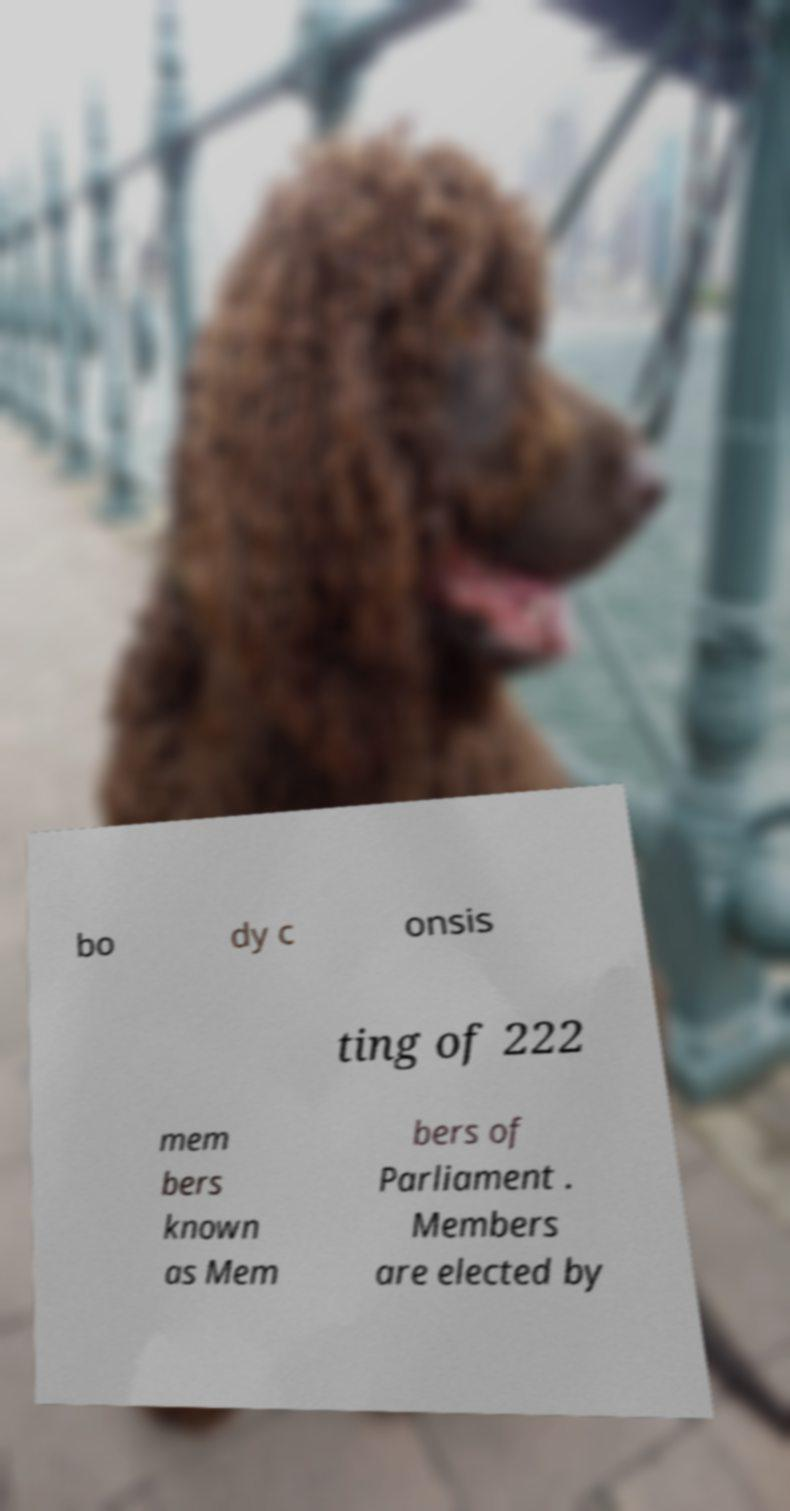Can you read and provide the text displayed in the image?This photo seems to have some interesting text. Can you extract and type it out for me? bo dy c onsis ting of 222 mem bers known as Mem bers of Parliament . Members are elected by 